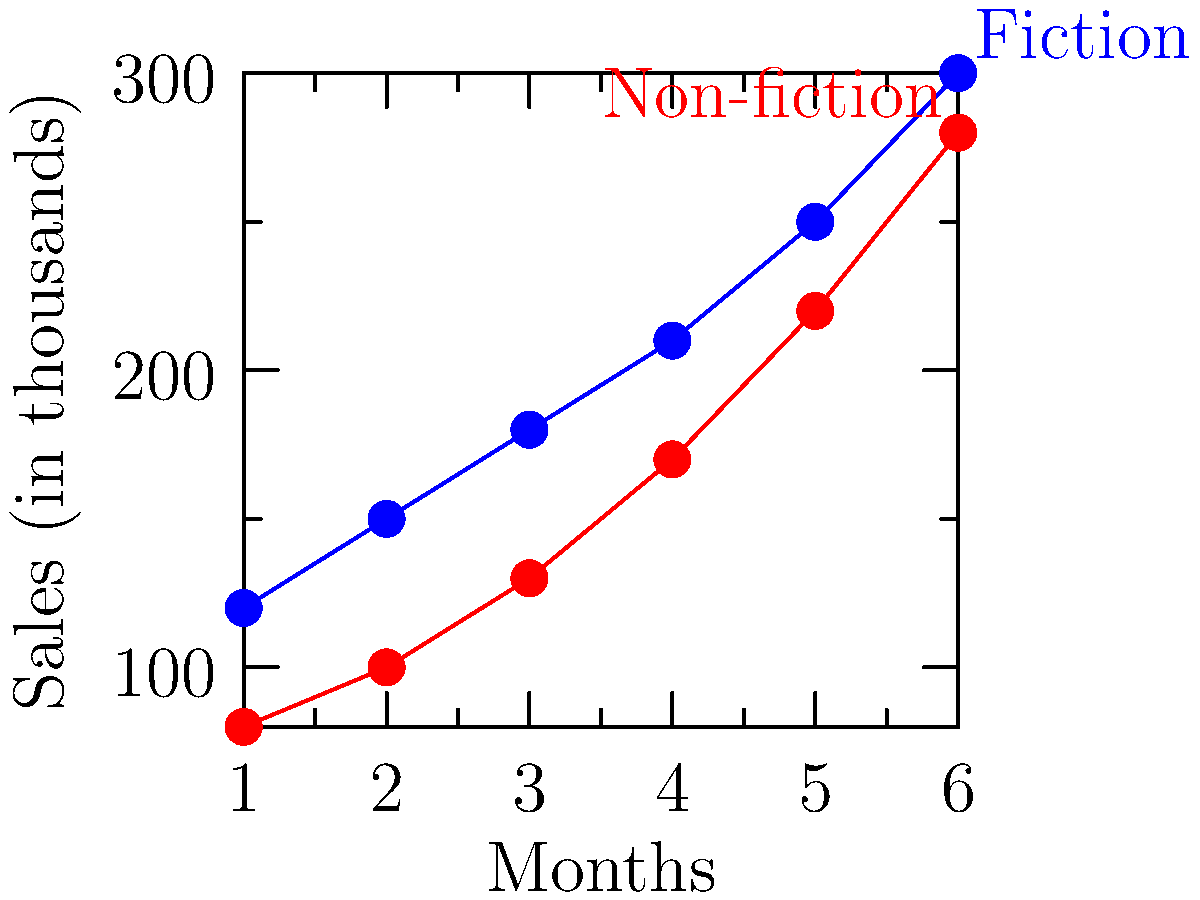As a market analyst, you're reviewing the book sales trends for fiction and non-fiction categories over a six-month period. Based on the line graph, what can you conclude about the relative growth rates of fiction and non-fiction book sales? To analyze the relative growth rates of fiction and non-fiction book sales, we need to examine the slopes of the lines representing each category:

1. Observe the starting points:
   - Fiction starts at about 120,000 sales in month 1
   - Non-fiction starts at about 80,000 sales in month 1

2. Observe the ending points:
   - Fiction ends at about 300,000 sales in month 6
   - Non-fiction ends at about 280,000 sales in month 6

3. Calculate the total growth for each category:
   - Fiction growth: 300,000 - 120,000 = 180,000
   - Non-fiction growth: 280,000 - 80,000 = 200,000

4. Compare the slopes of the lines:
   - The non-fiction line appears steeper, indicating a faster rate of growth

5. Calculate the growth rates:
   - Fiction growth rate: (180,000 / 120,000) * 100 = 150%
   - Non-fiction growth rate: (200,000 / 80,000) * 100 = 250%

6. Interpret the results:
   - Non-fiction has a higher growth rate (250%) compared to fiction (150%)
   - The lines are converging, with non-fiction sales catching up to fiction sales

Therefore, we can conclude that non-fiction book sales are growing at a faster rate than fiction book sales over the six-month period.
Answer: Non-fiction sales are growing faster than fiction sales. 